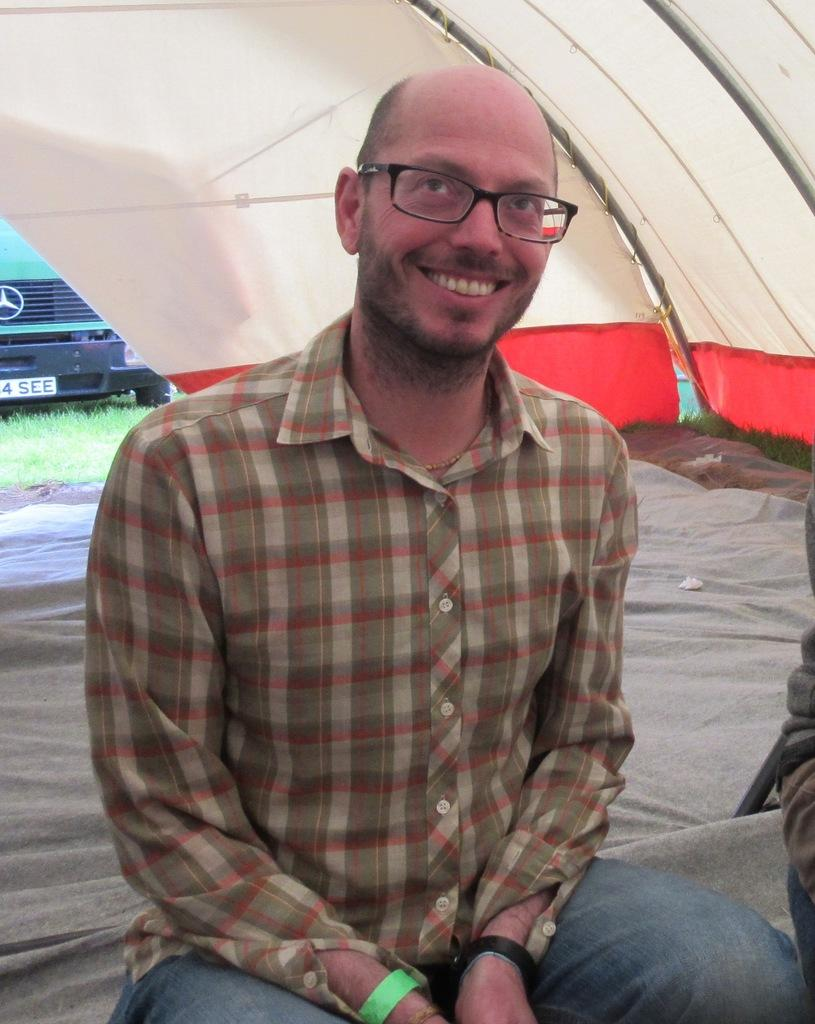What is the person sitting on in the image? The person is sitting on a cloth under a tent. What can be seen on the person's face in the image? The person is wearing spectacles. What type of terrain is visible in the image? There is a grassland visible in the image. Can you describe the presence of another person in the image? There is a person on the right side of the image. What type of caption is written on the person's shirt in the image? There is no caption visible on the person's shirt in the image. 